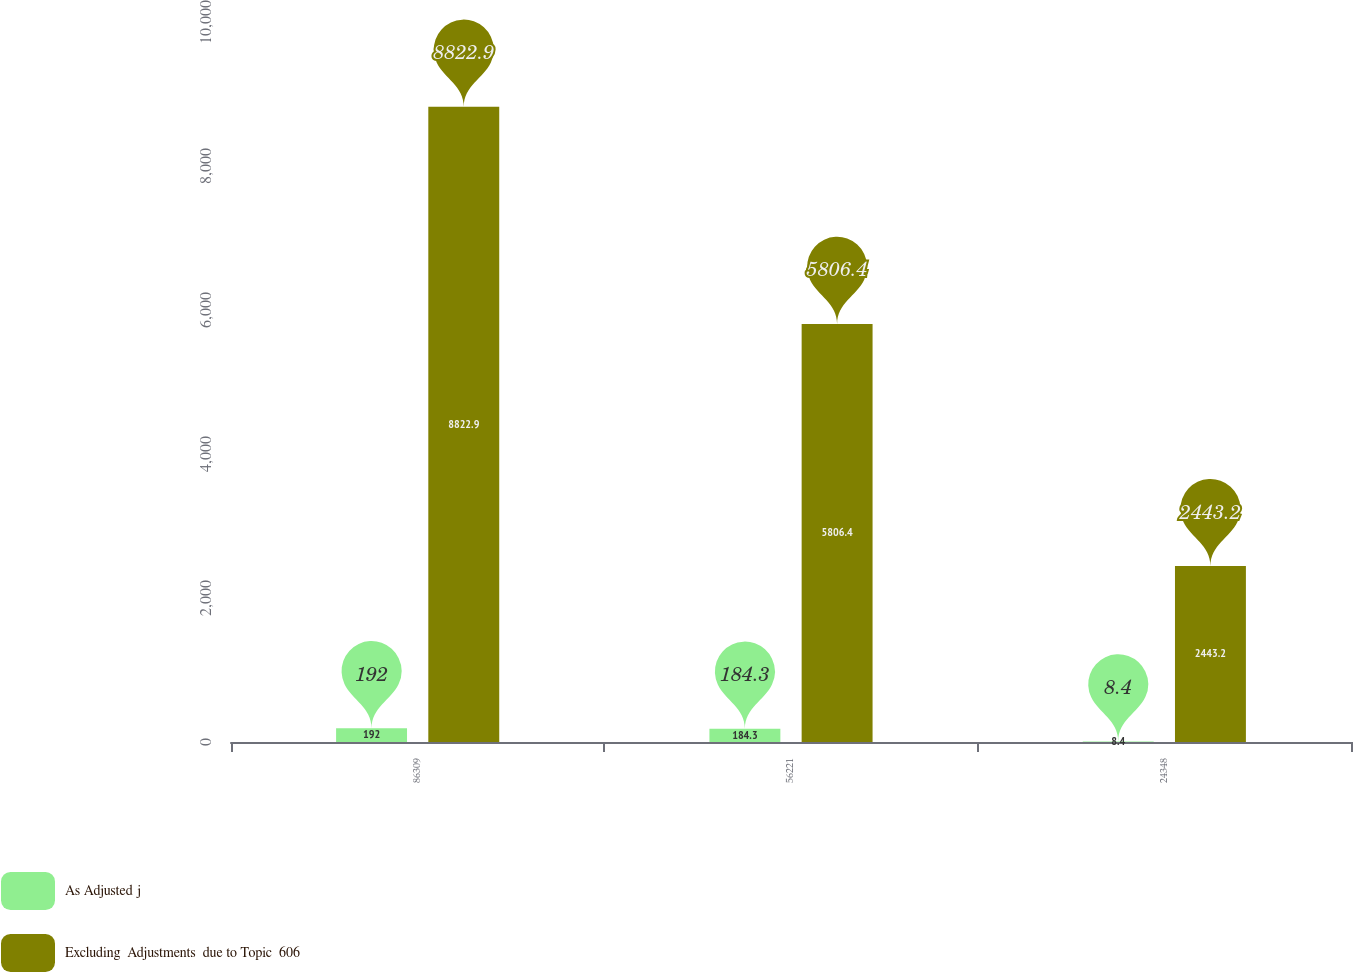Convert chart. <chart><loc_0><loc_0><loc_500><loc_500><stacked_bar_chart><ecel><fcel>86309<fcel>56221<fcel>24348<nl><fcel>As Adjusted j<fcel>192<fcel>184.3<fcel>8.4<nl><fcel>Excluding  Adjustments  due to Topic  606<fcel>8822.9<fcel>5806.4<fcel>2443.2<nl></chart> 